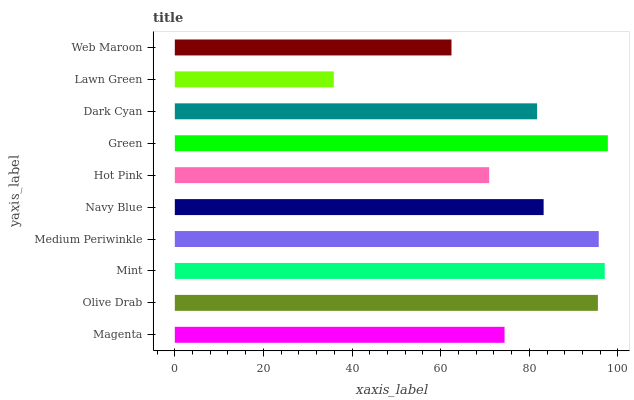Is Lawn Green the minimum?
Answer yes or no. Yes. Is Green the maximum?
Answer yes or no. Yes. Is Olive Drab the minimum?
Answer yes or no. No. Is Olive Drab the maximum?
Answer yes or no. No. Is Olive Drab greater than Magenta?
Answer yes or no. Yes. Is Magenta less than Olive Drab?
Answer yes or no. Yes. Is Magenta greater than Olive Drab?
Answer yes or no. No. Is Olive Drab less than Magenta?
Answer yes or no. No. Is Navy Blue the high median?
Answer yes or no. Yes. Is Dark Cyan the low median?
Answer yes or no. Yes. Is Lawn Green the high median?
Answer yes or no. No. Is Olive Drab the low median?
Answer yes or no. No. 